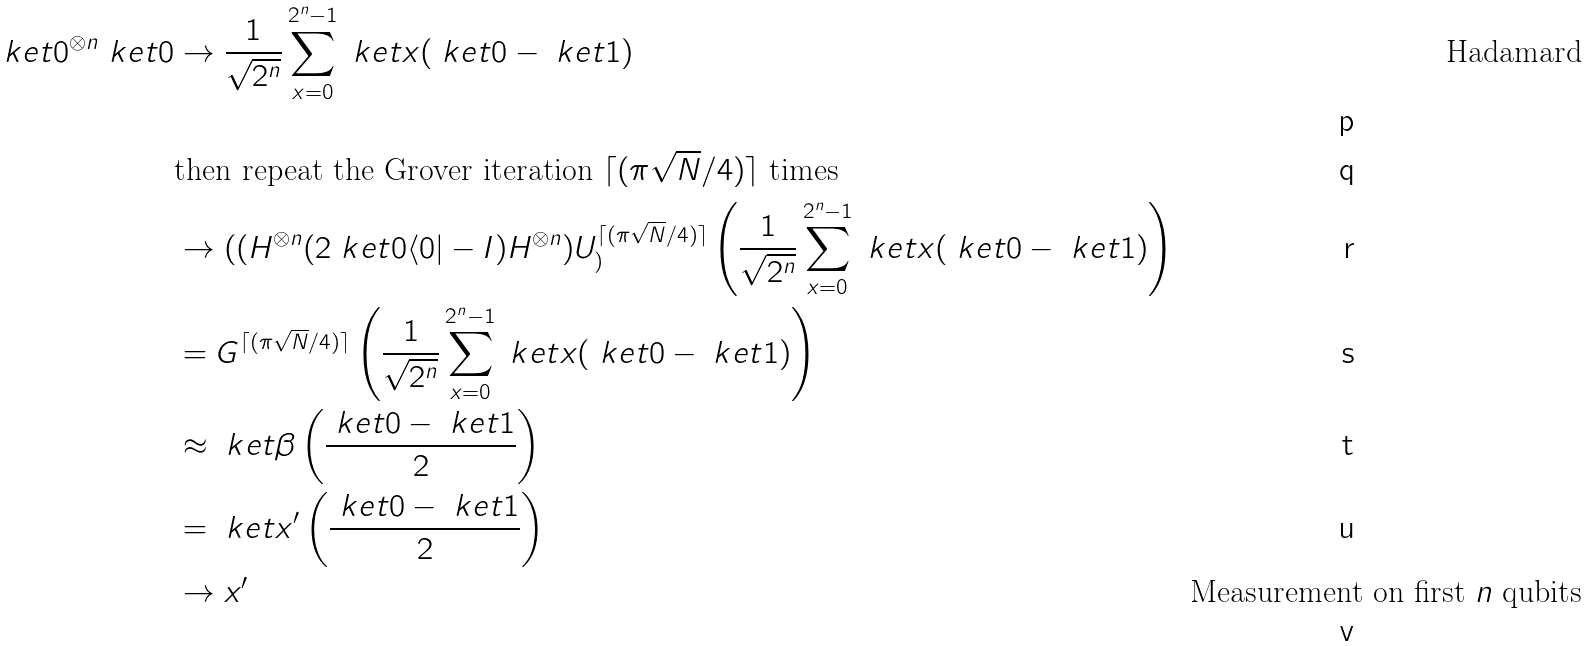Convert formula to latex. <formula><loc_0><loc_0><loc_500><loc_500>\ k e t { 0 } ^ { \otimes n } \ k e t { 0 } & \to \frac { 1 } { \sqrt { 2 ^ { n } } } \sum _ { x = 0 } ^ { 2 ^ { n } - 1 } \ k e t { x } ( \ k e t { 0 } - \ k e t { 1 } ) & \text {Hadamard} \\ & \text {then repeat the Grover iteration } \lceil ( \pi \sqrt { N } / 4 ) \rceil \text { times} \\ & \to ( ( H ^ { \otimes n } ( 2 \ k e t { 0 } \langle 0 | - I ) H ^ { \otimes n } ) U _ { ) } ^ { \lceil ( \pi \sqrt { N } / 4 ) \rceil } \left ( \frac { 1 } { \sqrt { 2 ^ { n } } } \sum _ { x = 0 } ^ { 2 ^ { n } - 1 } \ k e t { x } ( \ k e t { 0 } - \ k e t { 1 } ) \right ) \\ & = G ^ { \lceil ( \pi \sqrt { N } / 4 ) \rceil } \left ( \frac { 1 } { \sqrt { 2 ^ { n } } } \sum _ { x = 0 } ^ { 2 ^ { n } - 1 } \ k e t { x } ( \ k e t { 0 } - \ k e t { 1 } ) \right ) \\ & \approx \ k e t { \beta } \left ( \frac { \ k e t { 0 } - \ k e t { 1 } } { 2 } \right ) \\ & = \ k e t { x ^ { \prime } } \left ( \frac { \ k e t { 0 } - \ k e t { 1 } } { 2 } \right ) \\ & \to x ^ { \prime } & \text {Measurement on first $n$ qubits}</formula> 